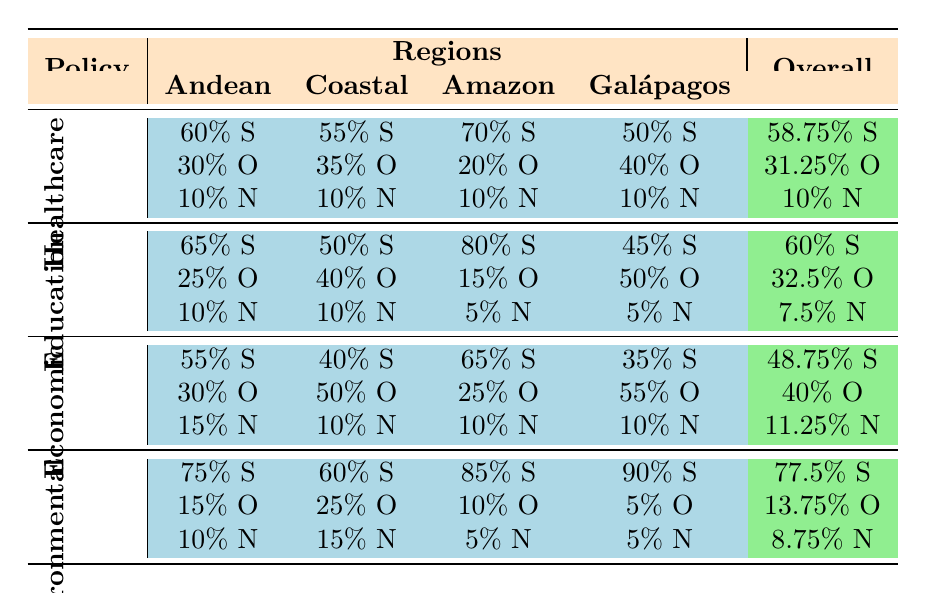What percentage of voters in the Coastal Region support Healthcare policies? According to the table, the percentage of voters in the Coastal Region who support Healthcare policies is directly listed as 55%.
Answer: 55% Which region shows the highest support for Environmental Policies? The table shows that the Amazon Region has 85% support and the Galápagos Islands have 90% support. Since 90% is higher, the Galápagos Islands show the highest support for Environmental Policies.
Answer: Galápagos Islands What is the overall percentage of voters who oppose Economic Policies? To find the overall percentage of opposition to Economic Policies, we take the averages of the opposing percentages: (30 + 50 + 25 + 55) / 4 = 40%. Thus, the overall percentage of voters opposing Economic Policies is 40%.
Answer: 40% Do more voters in the Andean Region support Education policies or Economic Policies? In the Andean Region, 65% support Education Policies while only 55% support Economic Policies. Since 65% is greater than 55%, more voters support Education policies.
Answer: Yes What is the average support percentage for Healthcare policies across all regions? The support percentages for Healthcare in the four regions are: Andean 60%, Coastal 55%, Amazon 70%, and Galápagos 50%. To find the average, we sum these percentages (60 + 55 + 70 + 50) = 235 and divide by 4 to get the average (235 / 4 = 58.75%).
Answer: 58.75% 